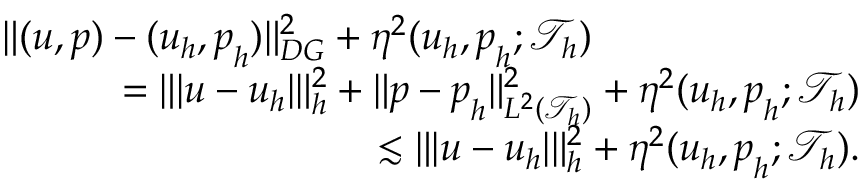Convert formula to latex. <formula><loc_0><loc_0><loc_500><loc_500>\begin{array} { r l r } { { \| ( u , p ) - ( u _ { h } , p _ { h } ) \| _ { D G } ^ { 2 } + \eta ^ { 2 } ( u _ { h } , p _ { h } ; \mathcal { T } _ { h } ) } } \\ & { \quad = \| | u - u _ { h } | \| _ { h } ^ { 2 } + \| p - p _ { h } \| _ { L ^ { 2 } ( \mathcal { T } _ { h } ) } ^ { 2 } + \eta ^ { 2 } ( u _ { h } , p _ { h } ; \mathcal { T } _ { h } ) } \\ & { \quad \lesssim \| | u - u _ { h } | \| _ { h } ^ { 2 } + \eta ^ { 2 } ( u _ { h } , p _ { h } ; \mathcal { T } _ { h } ) . } \end{array}</formula> 